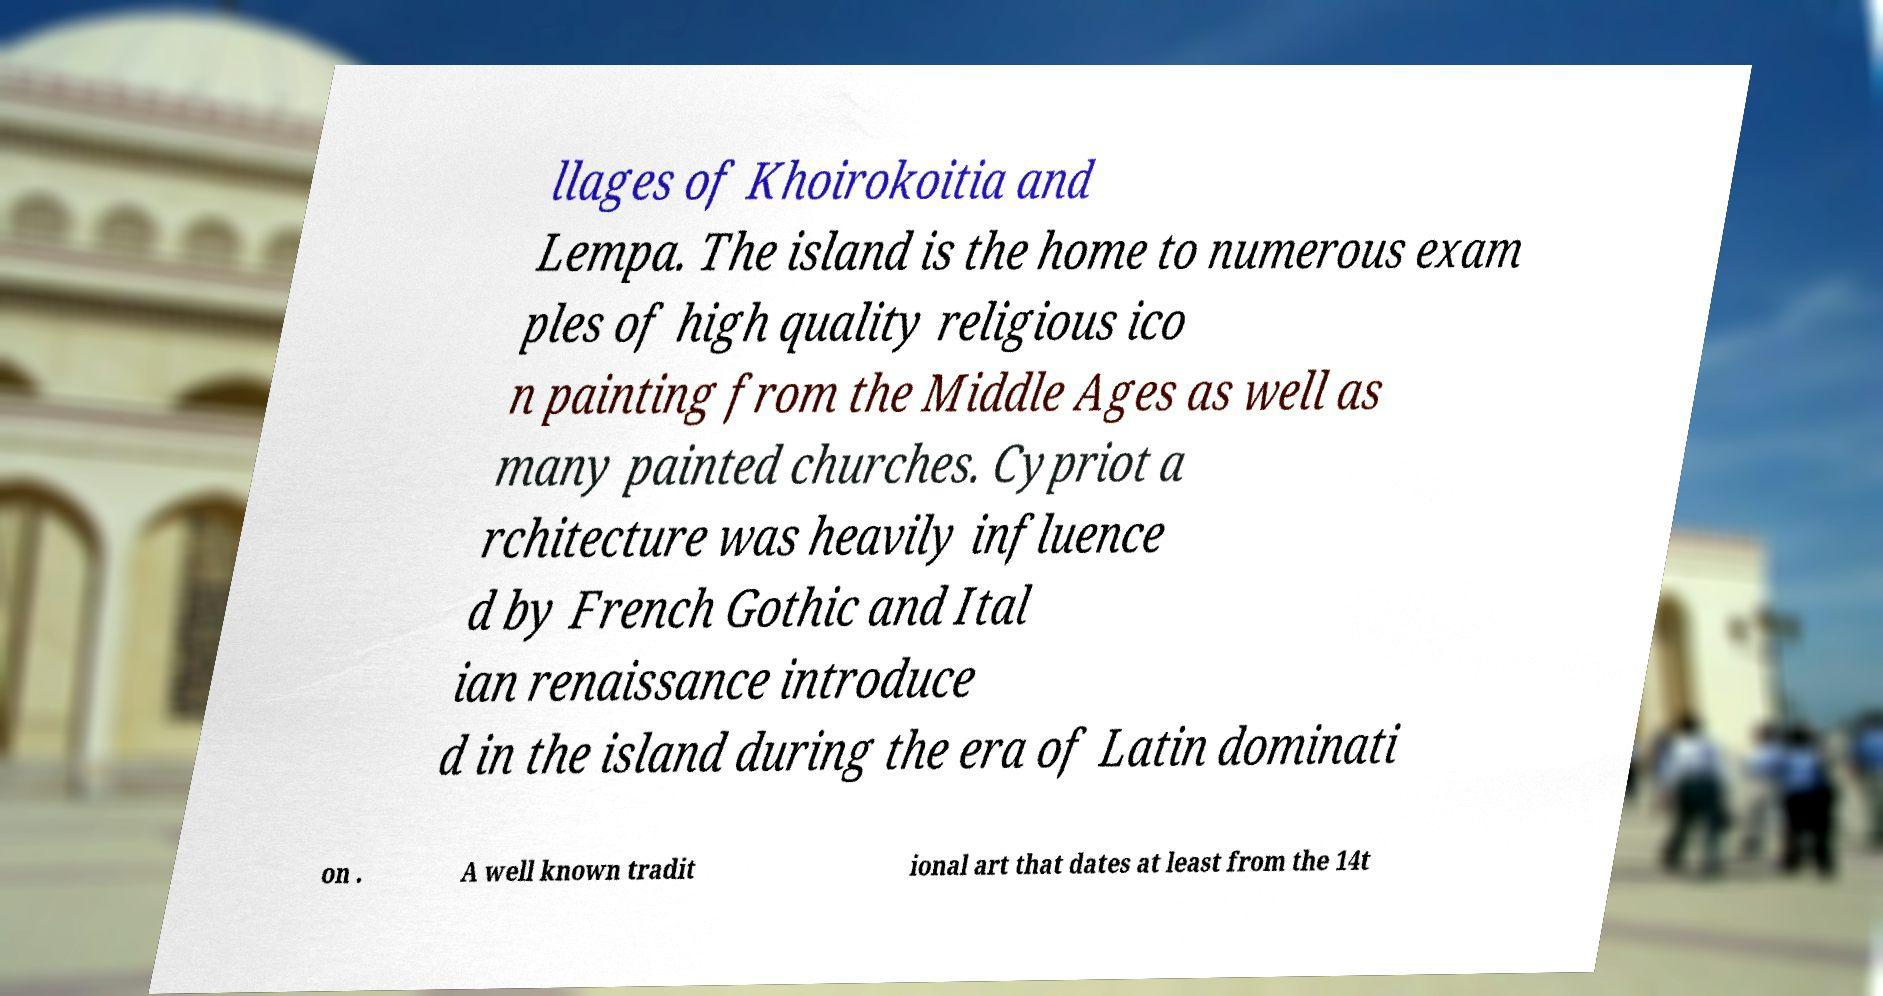Can you read and provide the text displayed in the image?This photo seems to have some interesting text. Can you extract and type it out for me? llages of Khoirokoitia and Lempa. The island is the home to numerous exam ples of high quality religious ico n painting from the Middle Ages as well as many painted churches. Cypriot a rchitecture was heavily influence d by French Gothic and Ital ian renaissance introduce d in the island during the era of Latin dominati on . A well known tradit ional art that dates at least from the 14t 